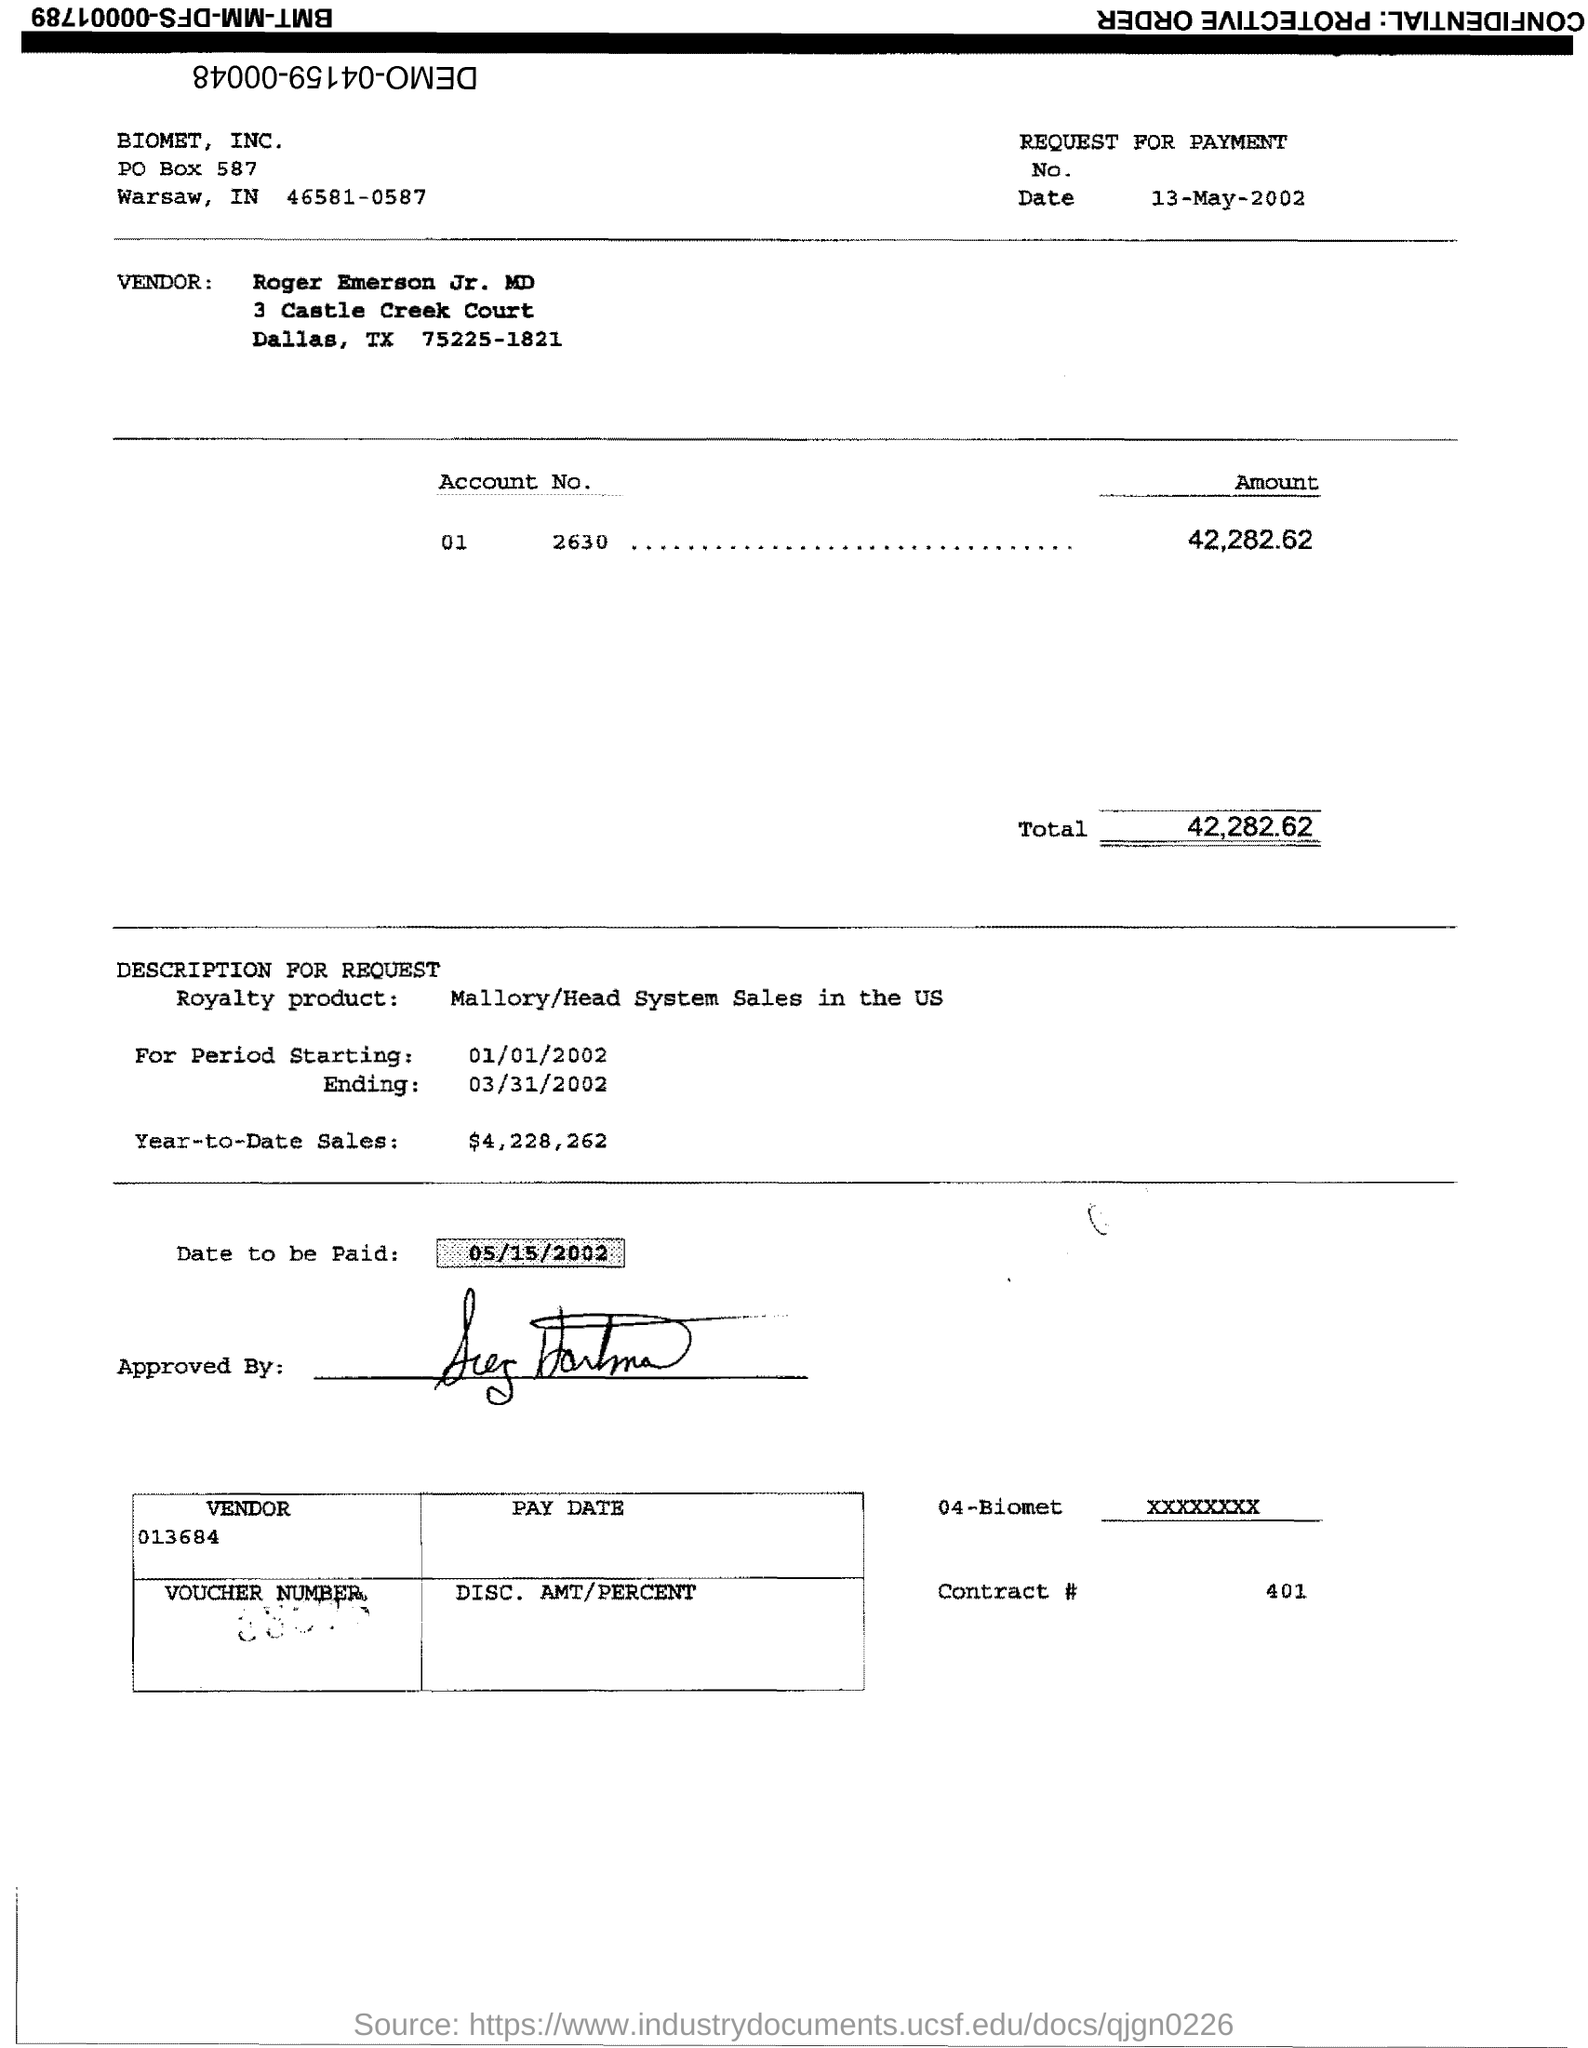Is there a signature on the document? Yes, there is a signature under the 'Approved By' section, indicating authorization of the payment request. 